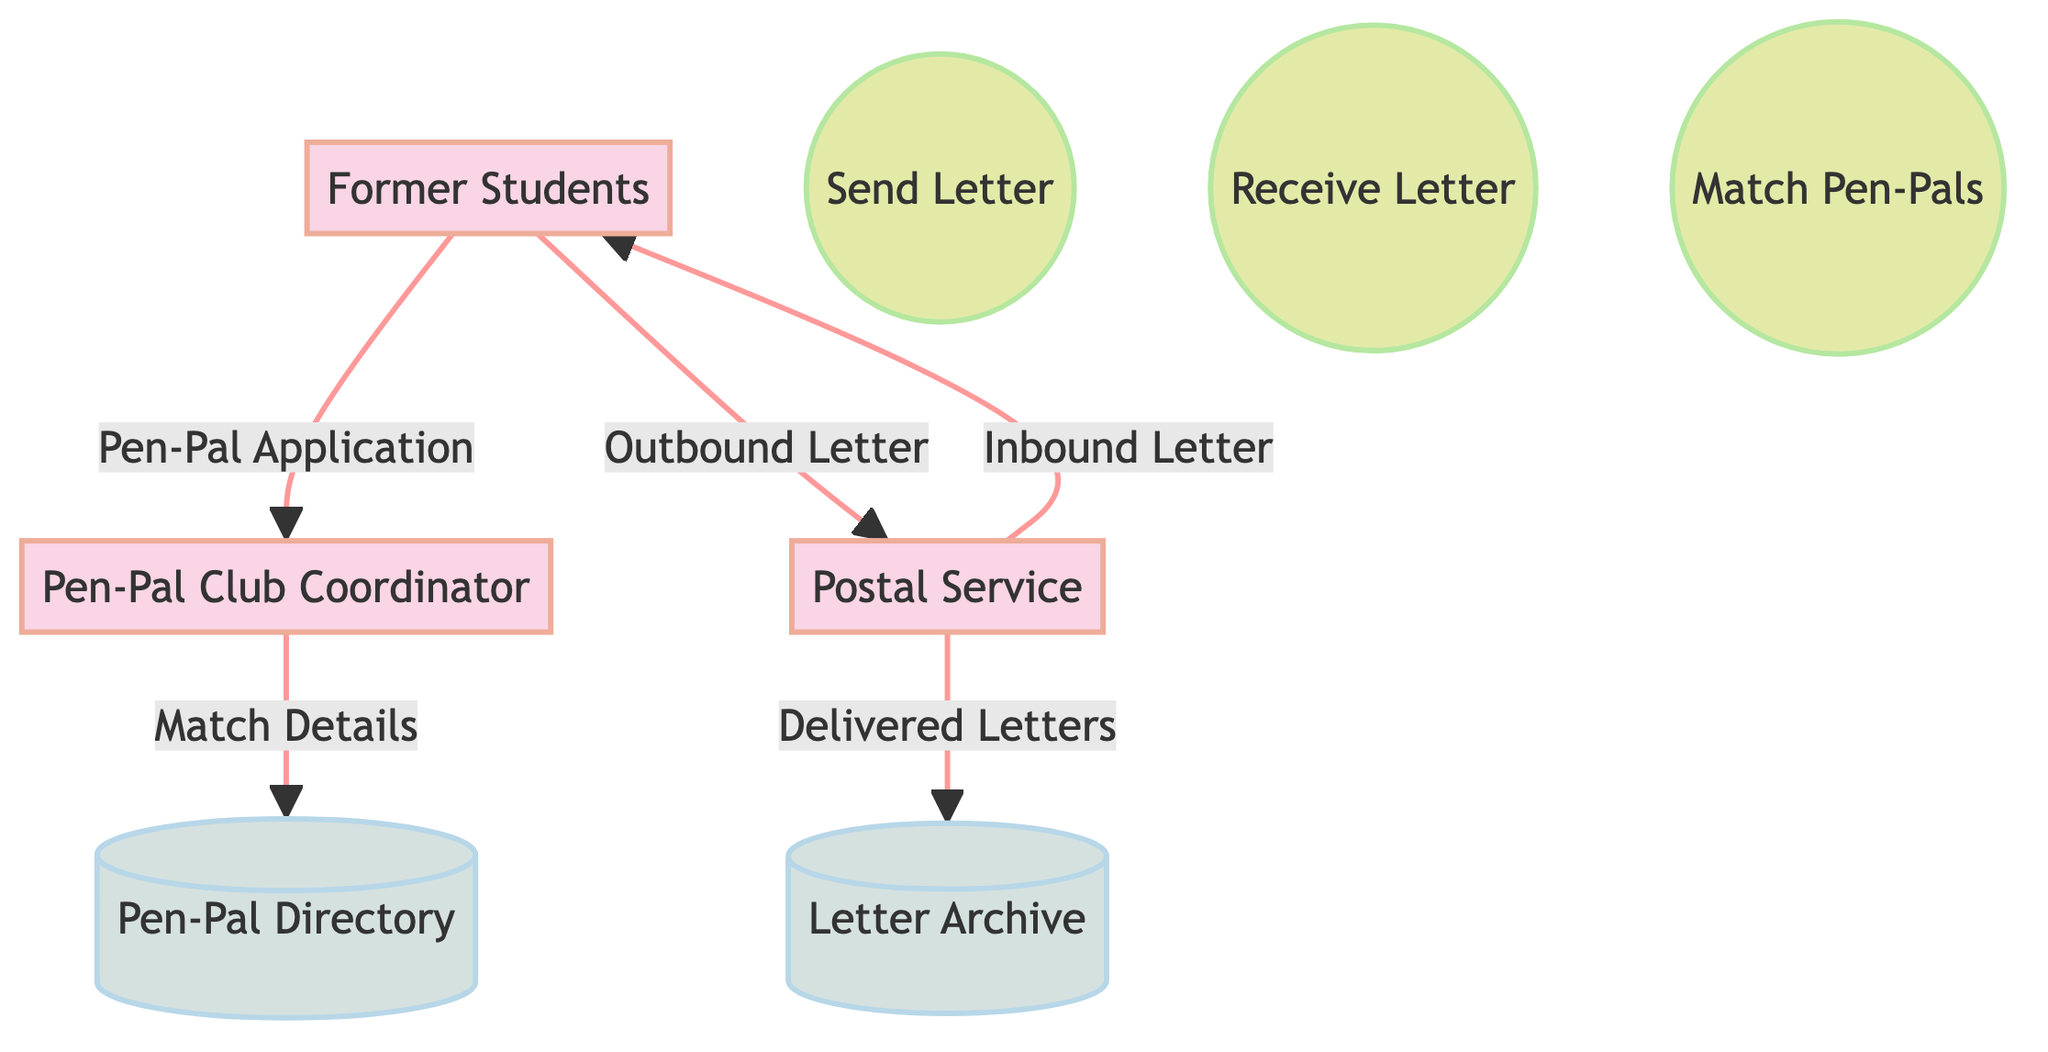What are the external entities in this diagram? The external entities listed in the diagram are Former Students, Pen-Pal Club Coordinator, and Postal Service. Each entity plays a role in the pen-pal communication system: Former Students participate, the Pen-Pal Club Coordinator manages pairings, and the Postal Service facilitates letter delivery.
Answer: Former Students, Pen-Pal Club Coordinator, Postal Service How many processes are in the diagram? The diagram clearly shows three processes labeled as Send Letter, Receive Letter, and Match Pen-Pals. A count of these processes gives us the total number in the diagram.
Answer: 3 What information do Former Students send to the Pen-Pal Club Coordinator? According to the data flow from Former Students to the Pen-Pal Club Coordinator, the process is described as Pen-Pal Application. This indicates that former students submit an application to join the communication system.
Answer: Pen-Pal Application What does the Pen-Pal Club Coordinator provide to the Pen-Pal Directory? The Pen-Pal Club Coordinator sends Match Details to the Pen-Pal Directory. This indicates that the coordinator organizes and records the pairing information for former students.
Answer: Match Details Which datastore is used for storing letters? The diagram specifies that the Letter Archive is a datastore used for storing letters. This indicates that it serves as a physical storage location for letters sent and received by the former students.
Answer: Letter Archive What is the purpose of the process labeled "Match Pen-Pals"? The purpose of the process "Match Pen-Pals" is to pair former students based on their interests, as described in the diagram. This highlights the role of the Pen-Pal Club Coordinator in creating compatible pen-pal matches.
Answer: To pair former students with each other based on their interests What is the flow from the Postal Service to Former Students? The flow from the Postal Service to Former Students is represented as Inbound Letter, indicating that this is the communication path for letters that arrive from a former student's pen-pal.
Answer: Inbound Letter What happens to delivered letters according to the data flow? Delivered Letters from the Postal Service are sent to the Letter Archive, indicating that copies of those letters are stored for record-keeping purposes. This reflects the process of maintaining a history of communications.
Answer: Delivered Letters 